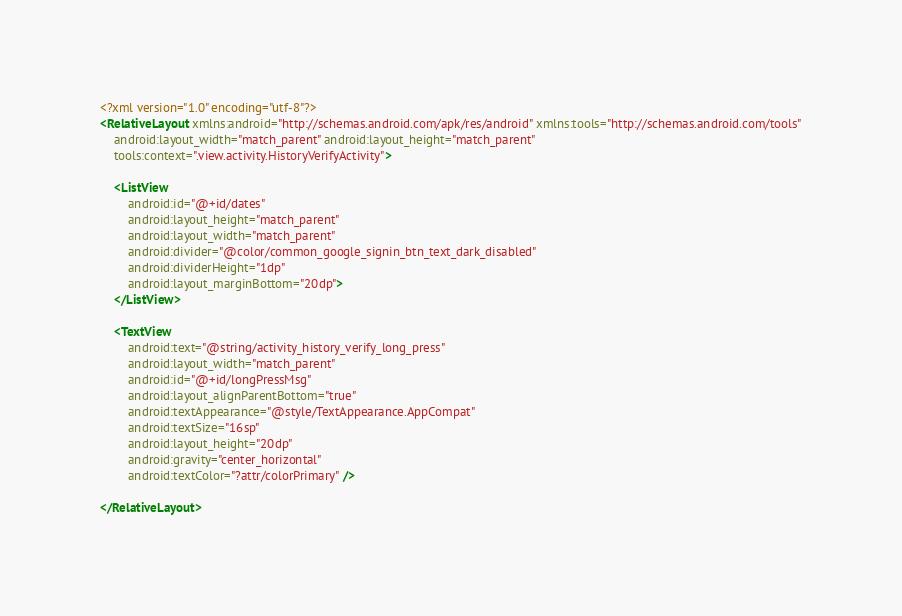Convert code to text. <code><loc_0><loc_0><loc_500><loc_500><_XML_><?xml version="1.0" encoding="utf-8"?>
<RelativeLayout xmlns:android="http://schemas.android.com/apk/res/android" xmlns:tools="http://schemas.android.com/tools"
    android:layout_width="match_parent" android:layout_height="match_parent"
    tools:context=".view.activity.HistoryVerifyActivity">

    <ListView
        android:id="@+id/dates"
        android:layout_height="match_parent"
        android:layout_width="match_parent"
        android:divider="@color/common_google_signin_btn_text_dark_disabled"
        android:dividerHeight="1dp"
        android:layout_marginBottom="20dp">
    </ListView>

    <TextView
        android:text="@string/activity_history_verify_long_press"
        android:layout_width="match_parent"
        android:id="@+id/longPressMsg"
        android:layout_alignParentBottom="true"
        android:textAppearance="@style/TextAppearance.AppCompat"
        android:textSize="16sp"
        android:layout_height="20dp"
        android:gravity="center_horizontal"
        android:textColor="?attr/colorPrimary" />

</RelativeLayout></code> 